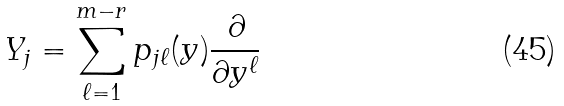Convert formula to latex. <formula><loc_0><loc_0><loc_500><loc_500>Y _ { j } = \sum _ { \ell = 1 } ^ { m - r } p _ { j { \ell } } ( y ) \frac { \partial } { \partial y ^ { \ell } }</formula> 